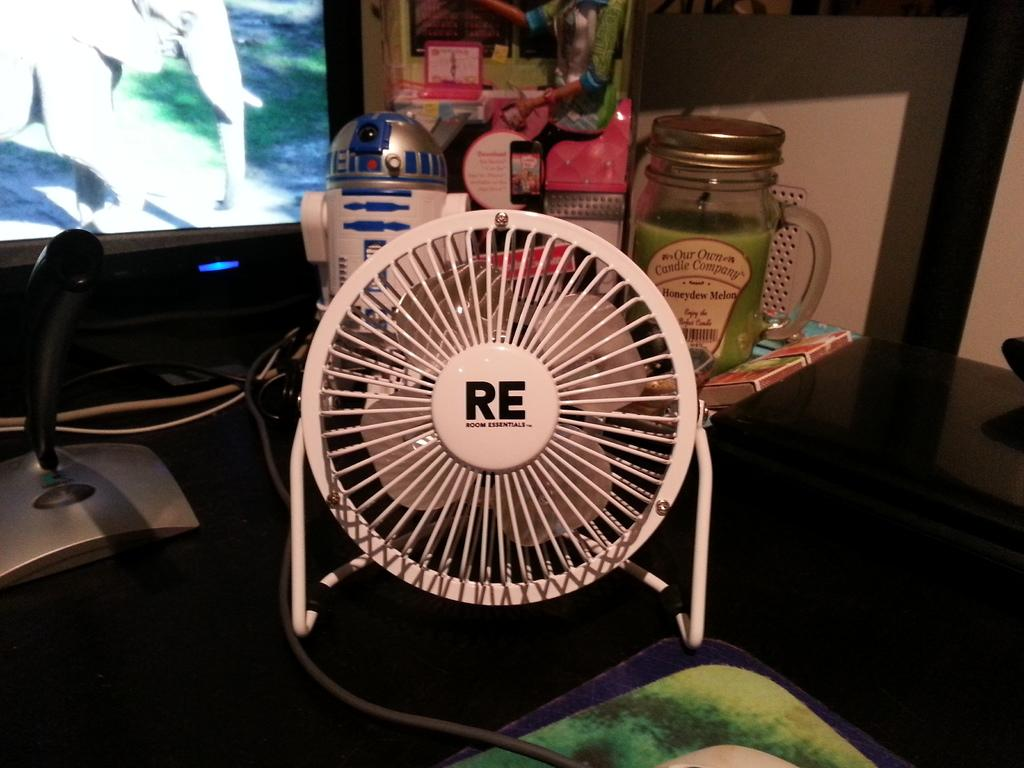What is one of the objects visible in the image? There is a jar in the image. What else can be seen on the same surface as the jar? There is a book in the image. What device is present in the image to provide air circulation? There is a table fan in the image. What type of wiring or connections might be visible in the image? Cables are present in the image. What time-keeping device is visible in the image? There is a clock in the image. What other objects can be found in the image besides those mentioned? There are other objects in the image, but their specific details are not provided. What type of electronic device is visible in the image? There is a television in the image. What type of background can be seen in the image? There is a wall in the image. What type of floor covering is present in the image? There is a mat on the floor in the image. How many thumbs are visible on the book in the image? There are no thumbs visible on the book in the image. What type of cub is playing with the jar in the image? There is no cub present in the image, and the jar is not being played with. 